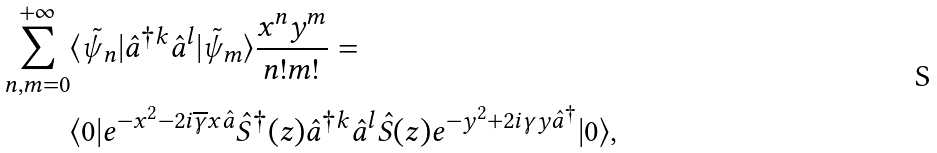Convert formula to latex. <formula><loc_0><loc_0><loc_500><loc_500>\sum ^ { + \infty } _ { n , m = 0 } & \langle \tilde { \psi } _ { n } | \hat { a } ^ { \dagger k } \hat { a } ^ { l } | \tilde { \psi } _ { m } \rangle \frac { x ^ { n } y ^ { m } } { n ! m ! } = \\ & \langle 0 | e ^ { - x ^ { 2 } - 2 i \overline { \gamma } x \hat { a } } \hat { S } ^ { \dagger } ( z ) \hat { a } ^ { \dagger k } \hat { a } ^ { l } \hat { S } ( z ) e ^ { - y ^ { 2 } + 2 i \gamma y \hat { a } ^ { \dagger } } | 0 \rangle ,</formula> 